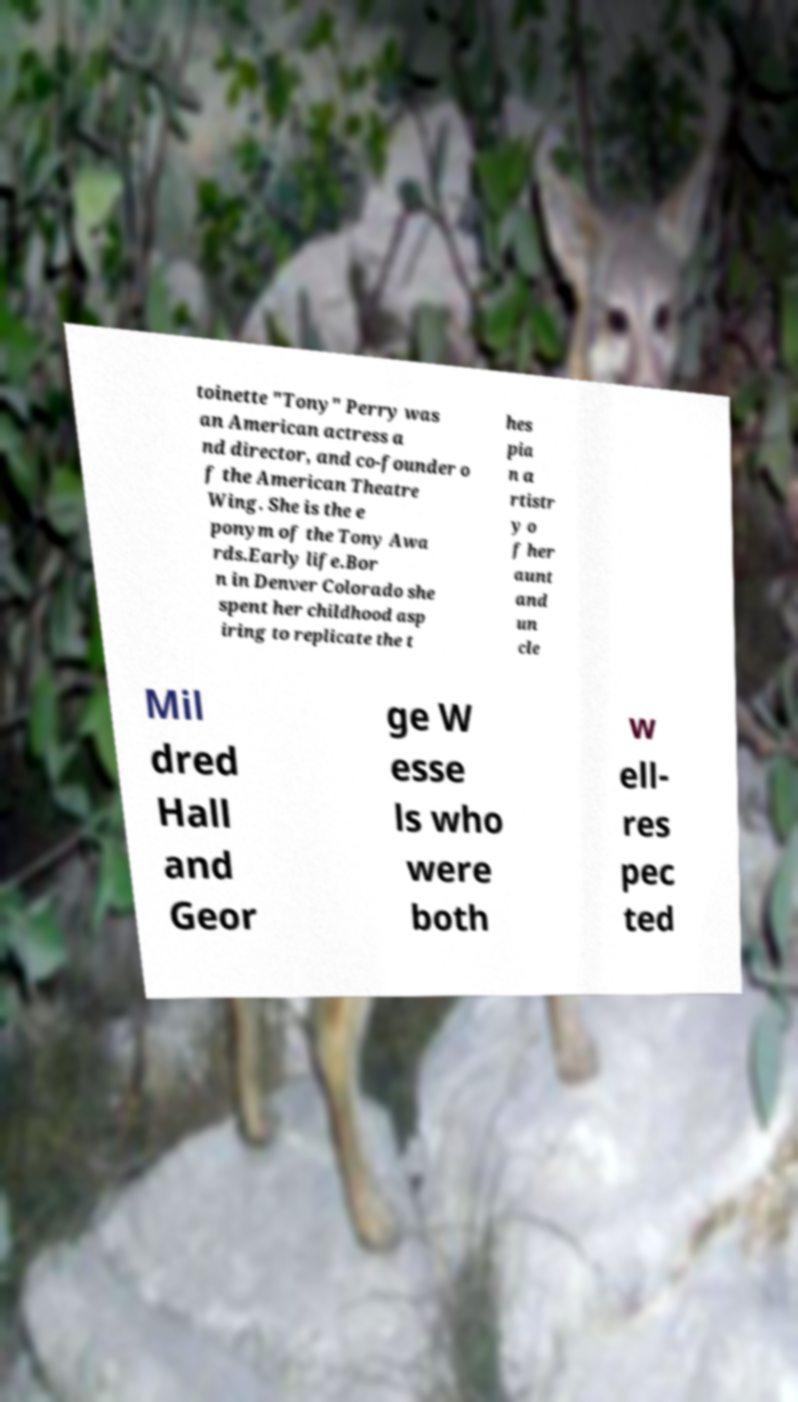I need the written content from this picture converted into text. Can you do that? toinette "Tony" Perry was an American actress a nd director, and co-founder o f the American Theatre Wing. She is the e ponym of the Tony Awa rds.Early life.Bor n in Denver Colorado she spent her childhood asp iring to replicate the t hes pia n a rtistr y o f her aunt and un cle Mil dred Hall and Geor ge W esse ls who were both w ell- res pec ted 